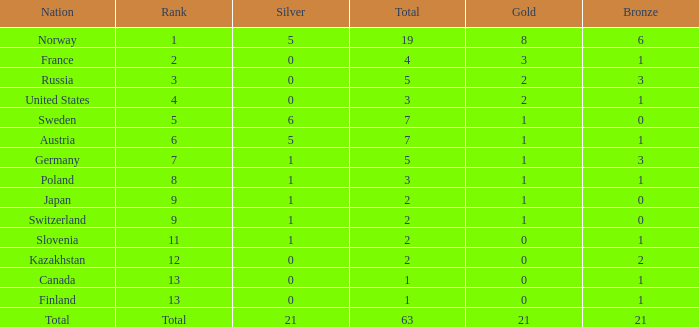What Rank has a gold smaller than 1, and a silver larger than 0? 11.0. 